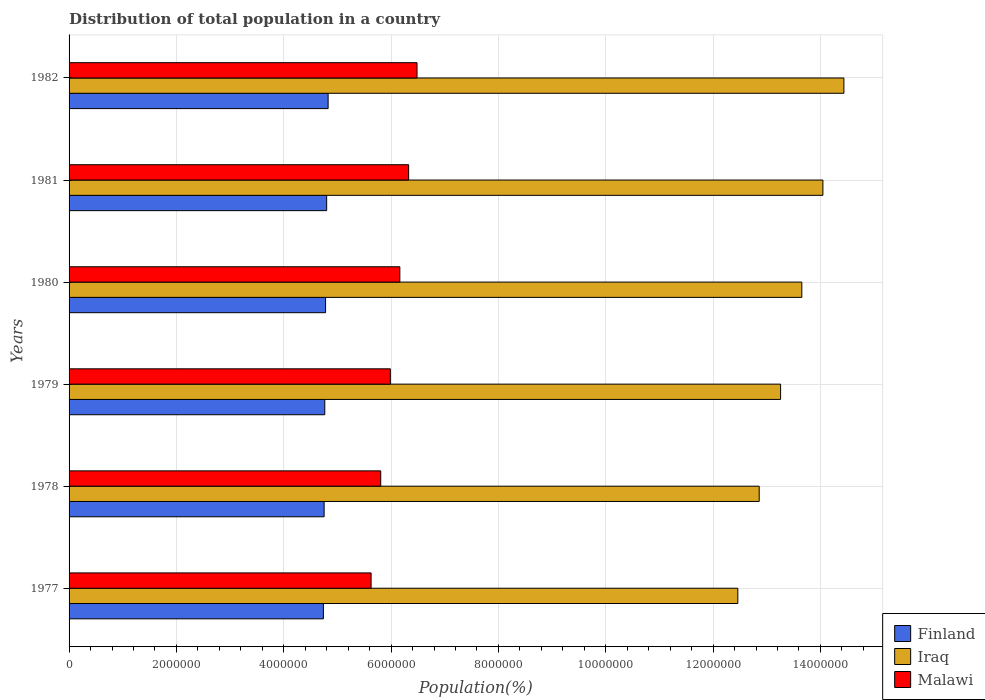How many groups of bars are there?
Your response must be concise. 6. How many bars are there on the 5th tick from the top?
Provide a succinct answer. 3. What is the label of the 6th group of bars from the top?
Offer a terse response. 1977. In how many cases, is the number of bars for a given year not equal to the number of legend labels?
Your answer should be compact. 0. What is the population of in Finland in 1982?
Offer a very short reply. 4.83e+06. Across all years, what is the maximum population of in Malawi?
Ensure brevity in your answer.  6.48e+06. Across all years, what is the minimum population of in Finland?
Provide a succinct answer. 4.74e+06. In which year was the population of in Finland maximum?
Your answer should be very brief. 1982. What is the total population of in Iraq in the graph?
Your response must be concise. 8.07e+07. What is the difference between the population of in Iraq in 1977 and that in 1982?
Provide a short and direct response. -1.98e+06. What is the difference between the population of in Iraq in 1980 and the population of in Malawi in 1977?
Ensure brevity in your answer.  8.03e+06. What is the average population of in Malawi per year?
Provide a short and direct response. 6.07e+06. In the year 1982, what is the difference between the population of in Malawi and population of in Iraq?
Your answer should be very brief. -7.95e+06. What is the ratio of the population of in Malawi in 1980 to that in 1981?
Offer a very short reply. 0.97. Is the population of in Malawi in 1977 less than that in 1980?
Keep it short and to the point. Yes. What is the difference between the highest and the second highest population of in Finland?
Ensure brevity in your answer.  2.70e+04. What is the difference between the highest and the lowest population of in Iraq?
Provide a short and direct response. 1.98e+06. Is the sum of the population of in Finland in 1980 and 1981 greater than the maximum population of in Malawi across all years?
Give a very brief answer. Yes. What does the 2nd bar from the top in 1978 represents?
Make the answer very short. Iraq. What does the 3rd bar from the bottom in 1977 represents?
Provide a succinct answer. Malawi. How many years are there in the graph?
Your answer should be compact. 6. What is the difference between two consecutive major ticks on the X-axis?
Your response must be concise. 2.00e+06. Where does the legend appear in the graph?
Make the answer very short. Bottom right. How many legend labels are there?
Ensure brevity in your answer.  3. How are the legend labels stacked?
Ensure brevity in your answer.  Vertical. What is the title of the graph?
Give a very brief answer. Distribution of total population in a country. What is the label or title of the X-axis?
Your response must be concise. Population(%). What is the label or title of the Y-axis?
Offer a terse response. Years. What is the Population(%) of Finland in 1977?
Keep it short and to the point. 4.74e+06. What is the Population(%) of Iraq in 1977?
Offer a terse response. 1.25e+07. What is the Population(%) of Malawi in 1977?
Provide a succinct answer. 5.63e+06. What is the Population(%) in Finland in 1978?
Offer a very short reply. 4.75e+06. What is the Population(%) of Iraq in 1978?
Ensure brevity in your answer.  1.29e+07. What is the Population(%) in Malawi in 1978?
Make the answer very short. 5.81e+06. What is the Population(%) in Finland in 1979?
Your response must be concise. 4.76e+06. What is the Population(%) of Iraq in 1979?
Your answer should be compact. 1.33e+07. What is the Population(%) of Malawi in 1979?
Provide a short and direct response. 5.99e+06. What is the Population(%) of Finland in 1980?
Provide a succinct answer. 4.78e+06. What is the Population(%) of Iraq in 1980?
Provide a short and direct response. 1.37e+07. What is the Population(%) of Malawi in 1980?
Offer a very short reply. 6.16e+06. What is the Population(%) of Finland in 1981?
Keep it short and to the point. 4.80e+06. What is the Population(%) of Iraq in 1981?
Offer a terse response. 1.40e+07. What is the Population(%) in Malawi in 1981?
Ensure brevity in your answer.  6.33e+06. What is the Population(%) in Finland in 1982?
Offer a terse response. 4.83e+06. What is the Population(%) of Iraq in 1982?
Ensure brevity in your answer.  1.44e+07. What is the Population(%) of Malawi in 1982?
Provide a succinct answer. 6.48e+06. Across all years, what is the maximum Population(%) of Finland?
Give a very brief answer. 4.83e+06. Across all years, what is the maximum Population(%) of Iraq?
Your answer should be compact. 1.44e+07. Across all years, what is the maximum Population(%) in Malawi?
Provide a succinct answer. 6.48e+06. Across all years, what is the minimum Population(%) of Finland?
Keep it short and to the point. 4.74e+06. Across all years, what is the minimum Population(%) in Iraq?
Your answer should be very brief. 1.25e+07. Across all years, what is the minimum Population(%) in Malawi?
Give a very brief answer. 5.63e+06. What is the total Population(%) of Finland in the graph?
Your answer should be compact. 2.87e+07. What is the total Population(%) of Iraq in the graph?
Make the answer very short. 8.07e+07. What is the total Population(%) of Malawi in the graph?
Offer a terse response. 3.64e+07. What is the difference between the Population(%) of Finland in 1977 and that in 1978?
Make the answer very short. -1.36e+04. What is the difference between the Population(%) of Iraq in 1977 and that in 1978?
Your answer should be compact. -3.98e+05. What is the difference between the Population(%) in Malawi in 1977 and that in 1978?
Provide a short and direct response. -1.79e+05. What is the difference between the Population(%) in Finland in 1977 and that in 1979?
Provide a short and direct response. -2.58e+04. What is the difference between the Population(%) of Iraq in 1977 and that in 1979?
Keep it short and to the point. -7.97e+05. What is the difference between the Population(%) in Malawi in 1977 and that in 1979?
Keep it short and to the point. -3.59e+05. What is the difference between the Population(%) in Finland in 1977 and that in 1980?
Give a very brief answer. -4.06e+04. What is the difference between the Population(%) of Iraq in 1977 and that in 1980?
Ensure brevity in your answer.  -1.19e+06. What is the difference between the Population(%) in Malawi in 1977 and that in 1980?
Provide a short and direct response. -5.35e+05. What is the difference between the Population(%) of Finland in 1977 and that in 1981?
Provide a succinct answer. -6.11e+04. What is the difference between the Population(%) of Iraq in 1977 and that in 1981?
Ensure brevity in your answer.  -1.59e+06. What is the difference between the Population(%) of Malawi in 1977 and that in 1981?
Your answer should be compact. -7.00e+05. What is the difference between the Population(%) of Finland in 1977 and that in 1982?
Your answer should be compact. -8.80e+04. What is the difference between the Population(%) of Iraq in 1977 and that in 1982?
Your answer should be very brief. -1.98e+06. What is the difference between the Population(%) in Malawi in 1977 and that in 1982?
Offer a very short reply. -8.56e+05. What is the difference between the Population(%) in Finland in 1978 and that in 1979?
Ensure brevity in your answer.  -1.22e+04. What is the difference between the Population(%) of Iraq in 1978 and that in 1979?
Offer a terse response. -3.99e+05. What is the difference between the Population(%) in Malawi in 1978 and that in 1979?
Offer a terse response. -1.79e+05. What is the difference between the Population(%) in Finland in 1978 and that in 1980?
Offer a very short reply. -2.70e+04. What is the difference between the Population(%) in Iraq in 1978 and that in 1980?
Keep it short and to the point. -7.94e+05. What is the difference between the Population(%) in Malawi in 1978 and that in 1980?
Provide a short and direct response. -3.56e+05. What is the difference between the Population(%) in Finland in 1978 and that in 1981?
Your answer should be compact. -4.74e+04. What is the difference between the Population(%) of Iraq in 1978 and that in 1981?
Your response must be concise. -1.19e+06. What is the difference between the Population(%) of Malawi in 1978 and that in 1981?
Make the answer very short. -5.20e+05. What is the difference between the Population(%) of Finland in 1978 and that in 1982?
Your answer should be very brief. -7.44e+04. What is the difference between the Population(%) in Iraq in 1978 and that in 1982?
Provide a short and direct response. -1.58e+06. What is the difference between the Population(%) of Malawi in 1978 and that in 1982?
Your response must be concise. -6.76e+05. What is the difference between the Population(%) of Finland in 1979 and that in 1980?
Your response must be concise. -1.48e+04. What is the difference between the Population(%) of Iraq in 1979 and that in 1980?
Give a very brief answer. -3.95e+05. What is the difference between the Population(%) of Malawi in 1979 and that in 1980?
Your response must be concise. -1.77e+05. What is the difference between the Population(%) of Finland in 1979 and that in 1981?
Your answer should be very brief. -3.53e+04. What is the difference between the Population(%) in Iraq in 1979 and that in 1981?
Offer a very short reply. -7.88e+05. What is the difference between the Population(%) of Malawi in 1979 and that in 1981?
Provide a short and direct response. -3.41e+05. What is the difference between the Population(%) in Finland in 1979 and that in 1982?
Provide a succinct answer. -6.22e+04. What is the difference between the Population(%) of Iraq in 1979 and that in 1982?
Offer a terse response. -1.18e+06. What is the difference between the Population(%) of Malawi in 1979 and that in 1982?
Keep it short and to the point. -4.97e+05. What is the difference between the Population(%) in Finland in 1980 and that in 1981?
Your response must be concise. -2.04e+04. What is the difference between the Population(%) in Iraq in 1980 and that in 1981?
Provide a short and direct response. -3.93e+05. What is the difference between the Population(%) of Malawi in 1980 and that in 1981?
Give a very brief answer. -1.64e+05. What is the difference between the Population(%) in Finland in 1980 and that in 1982?
Provide a short and direct response. -4.74e+04. What is the difference between the Population(%) of Iraq in 1980 and that in 1982?
Provide a short and direct response. -7.84e+05. What is the difference between the Population(%) in Malawi in 1980 and that in 1982?
Ensure brevity in your answer.  -3.20e+05. What is the difference between the Population(%) of Finland in 1981 and that in 1982?
Offer a terse response. -2.70e+04. What is the difference between the Population(%) in Iraq in 1981 and that in 1982?
Your response must be concise. -3.91e+05. What is the difference between the Population(%) of Malawi in 1981 and that in 1982?
Give a very brief answer. -1.56e+05. What is the difference between the Population(%) of Finland in 1977 and the Population(%) of Iraq in 1978?
Your answer should be very brief. -8.12e+06. What is the difference between the Population(%) in Finland in 1977 and the Population(%) in Malawi in 1978?
Keep it short and to the point. -1.07e+06. What is the difference between the Population(%) of Iraq in 1977 and the Population(%) of Malawi in 1978?
Your answer should be very brief. 6.65e+06. What is the difference between the Population(%) in Finland in 1977 and the Population(%) in Iraq in 1979?
Your response must be concise. -8.52e+06. What is the difference between the Population(%) in Finland in 1977 and the Population(%) in Malawi in 1979?
Provide a succinct answer. -1.25e+06. What is the difference between the Population(%) in Iraq in 1977 and the Population(%) in Malawi in 1979?
Keep it short and to the point. 6.47e+06. What is the difference between the Population(%) in Finland in 1977 and the Population(%) in Iraq in 1980?
Your answer should be compact. -8.91e+06. What is the difference between the Population(%) in Finland in 1977 and the Population(%) in Malawi in 1980?
Keep it short and to the point. -1.42e+06. What is the difference between the Population(%) of Iraq in 1977 and the Population(%) of Malawi in 1980?
Ensure brevity in your answer.  6.30e+06. What is the difference between the Population(%) of Finland in 1977 and the Population(%) of Iraq in 1981?
Give a very brief answer. -9.31e+06. What is the difference between the Population(%) of Finland in 1977 and the Population(%) of Malawi in 1981?
Your answer should be very brief. -1.59e+06. What is the difference between the Population(%) in Iraq in 1977 and the Population(%) in Malawi in 1981?
Your answer should be very brief. 6.13e+06. What is the difference between the Population(%) of Finland in 1977 and the Population(%) of Iraq in 1982?
Offer a very short reply. -9.70e+06. What is the difference between the Population(%) of Finland in 1977 and the Population(%) of Malawi in 1982?
Offer a very short reply. -1.74e+06. What is the difference between the Population(%) in Iraq in 1977 and the Population(%) in Malawi in 1982?
Provide a succinct answer. 5.98e+06. What is the difference between the Population(%) of Finland in 1978 and the Population(%) of Iraq in 1979?
Keep it short and to the point. -8.51e+06. What is the difference between the Population(%) of Finland in 1978 and the Population(%) of Malawi in 1979?
Your answer should be very brief. -1.23e+06. What is the difference between the Population(%) in Iraq in 1978 and the Population(%) in Malawi in 1979?
Provide a short and direct response. 6.87e+06. What is the difference between the Population(%) of Finland in 1978 and the Population(%) of Iraq in 1980?
Keep it short and to the point. -8.90e+06. What is the difference between the Population(%) of Finland in 1978 and the Population(%) of Malawi in 1980?
Keep it short and to the point. -1.41e+06. What is the difference between the Population(%) in Iraq in 1978 and the Population(%) in Malawi in 1980?
Your answer should be compact. 6.70e+06. What is the difference between the Population(%) of Finland in 1978 and the Population(%) of Iraq in 1981?
Your response must be concise. -9.29e+06. What is the difference between the Population(%) in Finland in 1978 and the Population(%) in Malawi in 1981?
Provide a short and direct response. -1.57e+06. What is the difference between the Population(%) of Iraq in 1978 and the Population(%) of Malawi in 1981?
Provide a succinct answer. 6.53e+06. What is the difference between the Population(%) of Finland in 1978 and the Population(%) of Iraq in 1982?
Provide a short and direct response. -9.69e+06. What is the difference between the Population(%) of Finland in 1978 and the Population(%) of Malawi in 1982?
Keep it short and to the point. -1.73e+06. What is the difference between the Population(%) in Iraq in 1978 and the Population(%) in Malawi in 1982?
Your answer should be very brief. 6.38e+06. What is the difference between the Population(%) of Finland in 1979 and the Population(%) of Iraq in 1980?
Give a very brief answer. -8.89e+06. What is the difference between the Population(%) in Finland in 1979 and the Population(%) in Malawi in 1980?
Provide a succinct answer. -1.40e+06. What is the difference between the Population(%) of Iraq in 1979 and the Population(%) of Malawi in 1980?
Your answer should be compact. 7.09e+06. What is the difference between the Population(%) in Finland in 1979 and the Population(%) in Iraq in 1981?
Make the answer very short. -9.28e+06. What is the difference between the Population(%) of Finland in 1979 and the Population(%) of Malawi in 1981?
Your answer should be compact. -1.56e+06. What is the difference between the Population(%) of Iraq in 1979 and the Population(%) of Malawi in 1981?
Keep it short and to the point. 6.93e+06. What is the difference between the Population(%) in Finland in 1979 and the Population(%) in Iraq in 1982?
Make the answer very short. -9.67e+06. What is the difference between the Population(%) of Finland in 1979 and the Population(%) of Malawi in 1982?
Provide a short and direct response. -1.72e+06. What is the difference between the Population(%) of Iraq in 1979 and the Population(%) of Malawi in 1982?
Offer a terse response. 6.77e+06. What is the difference between the Population(%) in Finland in 1980 and the Population(%) in Iraq in 1981?
Provide a short and direct response. -9.27e+06. What is the difference between the Population(%) in Finland in 1980 and the Population(%) in Malawi in 1981?
Offer a very short reply. -1.55e+06. What is the difference between the Population(%) in Iraq in 1980 and the Population(%) in Malawi in 1981?
Make the answer very short. 7.33e+06. What is the difference between the Population(%) of Finland in 1980 and the Population(%) of Iraq in 1982?
Offer a terse response. -9.66e+06. What is the difference between the Population(%) of Finland in 1980 and the Population(%) of Malawi in 1982?
Make the answer very short. -1.70e+06. What is the difference between the Population(%) of Iraq in 1980 and the Population(%) of Malawi in 1982?
Your response must be concise. 7.17e+06. What is the difference between the Population(%) of Finland in 1981 and the Population(%) of Iraq in 1982?
Offer a very short reply. -9.64e+06. What is the difference between the Population(%) of Finland in 1981 and the Population(%) of Malawi in 1982?
Ensure brevity in your answer.  -1.68e+06. What is the difference between the Population(%) in Iraq in 1981 and the Population(%) in Malawi in 1982?
Offer a terse response. 7.56e+06. What is the average Population(%) in Finland per year?
Offer a terse response. 4.78e+06. What is the average Population(%) in Iraq per year?
Provide a short and direct response. 1.35e+07. What is the average Population(%) in Malawi per year?
Make the answer very short. 6.07e+06. In the year 1977, what is the difference between the Population(%) in Finland and Population(%) in Iraq?
Your response must be concise. -7.72e+06. In the year 1977, what is the difference between the Population(%) of Finland and Population(%) of Malawi?
Keep it short and to the point. -8.89e+05. In the year 1977, what is the difference between the Population(%) of Iraq and Population(%) of Malawi?
Provide a succinct answer. 6.83e+06. In the year 1978, what is the difference between the Population(%) of Finland and Population(%) of Iraq?
Make the answer very short. -8.11e+06. In the year 1978, what is the difference between the Population(%) of Finland and Population(%) of Malawi?
Provide a succinct answer. -1.05e+06. In the year 1978, what is the difference between the Population(%) in Iraq and Population(%) in Malawi?
Your answer should be very brief. 7.05e+06. In the year 1979, what is the difference between the Population(%) in Finland and Population(%) in Iraq?
Provide a short and direct response. -8.49e+06. In the year 1979, what is the difference between the Population(%) in Finland and Population(%) in Malawi?
Provide a succinct answer. -1.22e+06. In the year 1979, what is the difference between the Population(%) of Iraq and Population(%) of Malawi?
Your answer should be very brief. 7.27e+06. In the year 1980, what is the difference between the Population(%) in Finland and Population(%) in Iraq?
Provide a short and direct response. -8.87e+06. In the year 1980, what is the difference between the Population(%) in Finland and Population(%) in Malawi?
Offer a very short reply. -1.38e+06. In the year 1980, what is the difference between the Population(%) in Iraq and Population(%) in Malawi?
Offer a terse response. 7.49e+06. In the year 1981, what is the difference between the Population(%) in Finland and Population(%) in Iraq?
Ensure brevity in your answer.  -9.25e+06. In the year 1981, what is the difference between the Population(%) in Finland and Population(%) in Malawi?
Ensure brevity in your answer.  -1.53e+06. In the year 1981, what is the difference between the Population(%) of Iraq and Population(%) of Malawi?
Ensure brevity in your answer.  7.72e+06. In the year 1982, what is the difference between the Population(%) of Finland and Population(%) of Iraq?
Give a very brief answer. -9.61e+06. In the year 1982, what is the difference between the Population(%) of Finland and Population(%) of Malawi?
Ensure brevity in your answer.  -1.66e+06. In the year 1982, what is the difference between the Population(%) of Iraq and Population(%) of Malawi?
Your answer should be compact. 7.95e+06. What is the ratio of the Population(%) of Iraq in 1977 to that in 1978?
Your answer should be compact. 0.97. What is the ratio of the Population(%) in Malawi in 1977 to that in 1978?
Your answer should be very brief. 0.97. What is the ratio of the Population(%) of Finland in 1977 to that in 1979?
Make the answer very short. 0.99. What is the ratio of the Population(%) in Iraq in 1977 to that in 1979?
Keep it short and to the point. 0.94. What is the ratio of the Population(%) of Malawi in 1977 to that in 1979?
Keep it short and to the point. 0.94. What is the ratio of the Population(%) of Iraq in 1977 to that in 1980?
Your response must be concise. 0.91. What is the ratio of the Population(%) in Malawi in 1977 to that in 1980?
Provide a succinct answer. 0.91. What is the ratio of the Population(%) in Finland in 1977 to that in 1981?
Keep it short and to the point. 0.99. What is the ratio of the Population(%) of Iraq in 1977 to that in 1981?
Offer a terse response. 0.89. What is the ratio of the Population(%) of Malawi in 1977 to that in 1981?
Your answer should be very brief. 0.89. What is the ratio of the Population(%) in Finland in 1977 to that in 1982?
Give a very brief answer. 0.98. What is the ratio of the Population(%) in Iraq in 1977 to that in 1982?
Offer a very short reply. 0.86. What is the ratio of the Population(%) of Malawi in 1977 to that in 1982?
Your answer should be compact. 0.87. What is the ratio of the Population(%) in Finland in 1978 to that in 1979?
Provide a succinct answer. 1. What is the ratio of the Population(%) in Iraq in 1978 to that in 1979?
Your answer should be very brief. 0.97. What is the ratio of the Population(%) of Malawi in 1978 to that in 1979?
Provide a succinct answer. 0.97. What is the ratio of the Population(%) of Finland in 1978 to that in 1980?
Provide a succinct answer. 0.99. What is the ratio of the Population(%) in Iraq in 1978 to that in 1980?
Ensure brevity in your answer.  0.94. What is the ratio of the Population(%) in Malawi in 1978 to that in 1980?
Offer a very short reply. 0.94. What is the ratio of the Population(%) of Finland in 1978 to that in 1981?
Offer a very short reply. 0.99. What is the ratio of the Population(%) in Iraq in 1978 to that in 1981?
Offer a terse response. 0.92. What is the ratio of the Population(%) in Malawi in 1978 to that in 1981?
Your response must be concise. 0.92. What is the ratio of the Population(%) of Finland in 1978 to that in 1982?
Provide a short and direct response. 0.98. What is the ratio of the Population(%) in Iraq in 1978 to that in 1982?
Make the answer very short. 0.89. What is the ratio of the Population(%) of Malawi in 1978 to that in 1982?
Offer a very short reply. 0.9. What is the ratio of the Population(%) of Finland in 1979 to that in 1980?
Give a very brief answer. 1. What is the ratio of the Population(%) in Iraq in 1979 to that in 1980?
Provide a short and direct response. 0.97. What is the ratio of the Population(%) in Malawi in 1979 to that in 1980?
Give a very brief answer. 0.97. What is the ratio of the Population(%) in Iraq in 1979 to that in 1981?
Give a very brief answer. 0.94. What is the ratio of the Population(%) in Malawi in 1979 to that in 1981?
Your answer should be very brief. 0.95. What is the ratio of the Population(%) in Finland in 1979 to that in 1982?
Provide a short and direct response. 0.99. What is the ratio of the Population(%) in Iraq in 1979 to that in 1982?
Your answer should be very brief. 0.92. What is the ratio of the Population(%) in Malawi in 1979 to that in 1982?
Offer a terse response. 0.92. What is the ratio of the Population(%) of Finland in 1980 to that in 1981?
Provide a succinct answer. 1. What is the ratio of the Population(%) of Iraq in 1980 to that in 1981?
Your answer should be compact. 0.97. What is the ratio of the Population(%) in Malawi in 1980 to that in 1981?
Ensure brevity in your answer.  0.97. What is the ratio of the Population(%) in Finland in 1980 to that in 1982?
Keep it short and to the point. 0.99. What is the ratio of the Population(%) of Iraq in 1980 to that in 1982?
Keep it short and to the point. 0.95. What is the ratio of the Population(%) in Malawi in 1980 to that in 1982?
Your answer should be compact. 0.95. What is the ratio of the Population(%) of Finland in 1981 to that in 1982?
Your answer should be very brief. 0.99. What is the ratio of the Population(%) in Iraq in 1981 to that in 1982?
Make the answer very short. 0.97. What is the ratio of the Population(%) in Malawi in 1981 to that in 1982?
Ensure brevity in your answer.  0.98. What is the difference between the highest and the second highest Population(%) in Finland?
Your answer should be compact. 2.70e+04. What is the difference between the highest and the second highest Population(%) of Iraq?
Make the answer very short. 3.91e+05. What is the difference between the highest and the second highest Population(%) of Malawi?
Keep it short and to the point. 1.56e+05. What is the difference between the highest and the lowest Population(%) in Finland?
Offer a very short reply. 8.80e+04. What is the difference between the highest and the lowest Population(%) of Iraq?
Your response must be concise. 1.98e+06. What is the difference between the highest and the lowest Population(%) in Malawi?
Offer a terse response. 8.56e+05. 